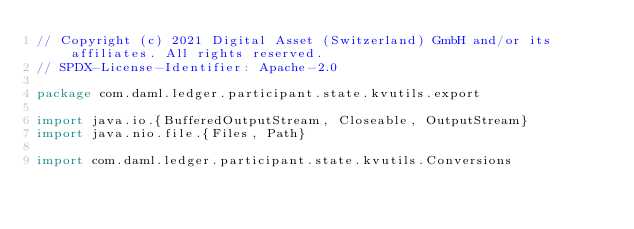<code> <loc_0><loc_0><loc_500><loc_500><_Scala_>// Copyright (c) 2021 Digital Asset (Switzerland) GmbH and/or its affiliates. All rights reserved.
// SPDX-License-Identifier: Apache-2.0

package com.daml.ledger.participant.state.kvutils.export

import java.io.{BufferedOutputStream, Closeable, OutputStream}
import java.nio.file.{Files, Path}

import com.daml.ledger.participant.state.kvutils.Conversions</code> 